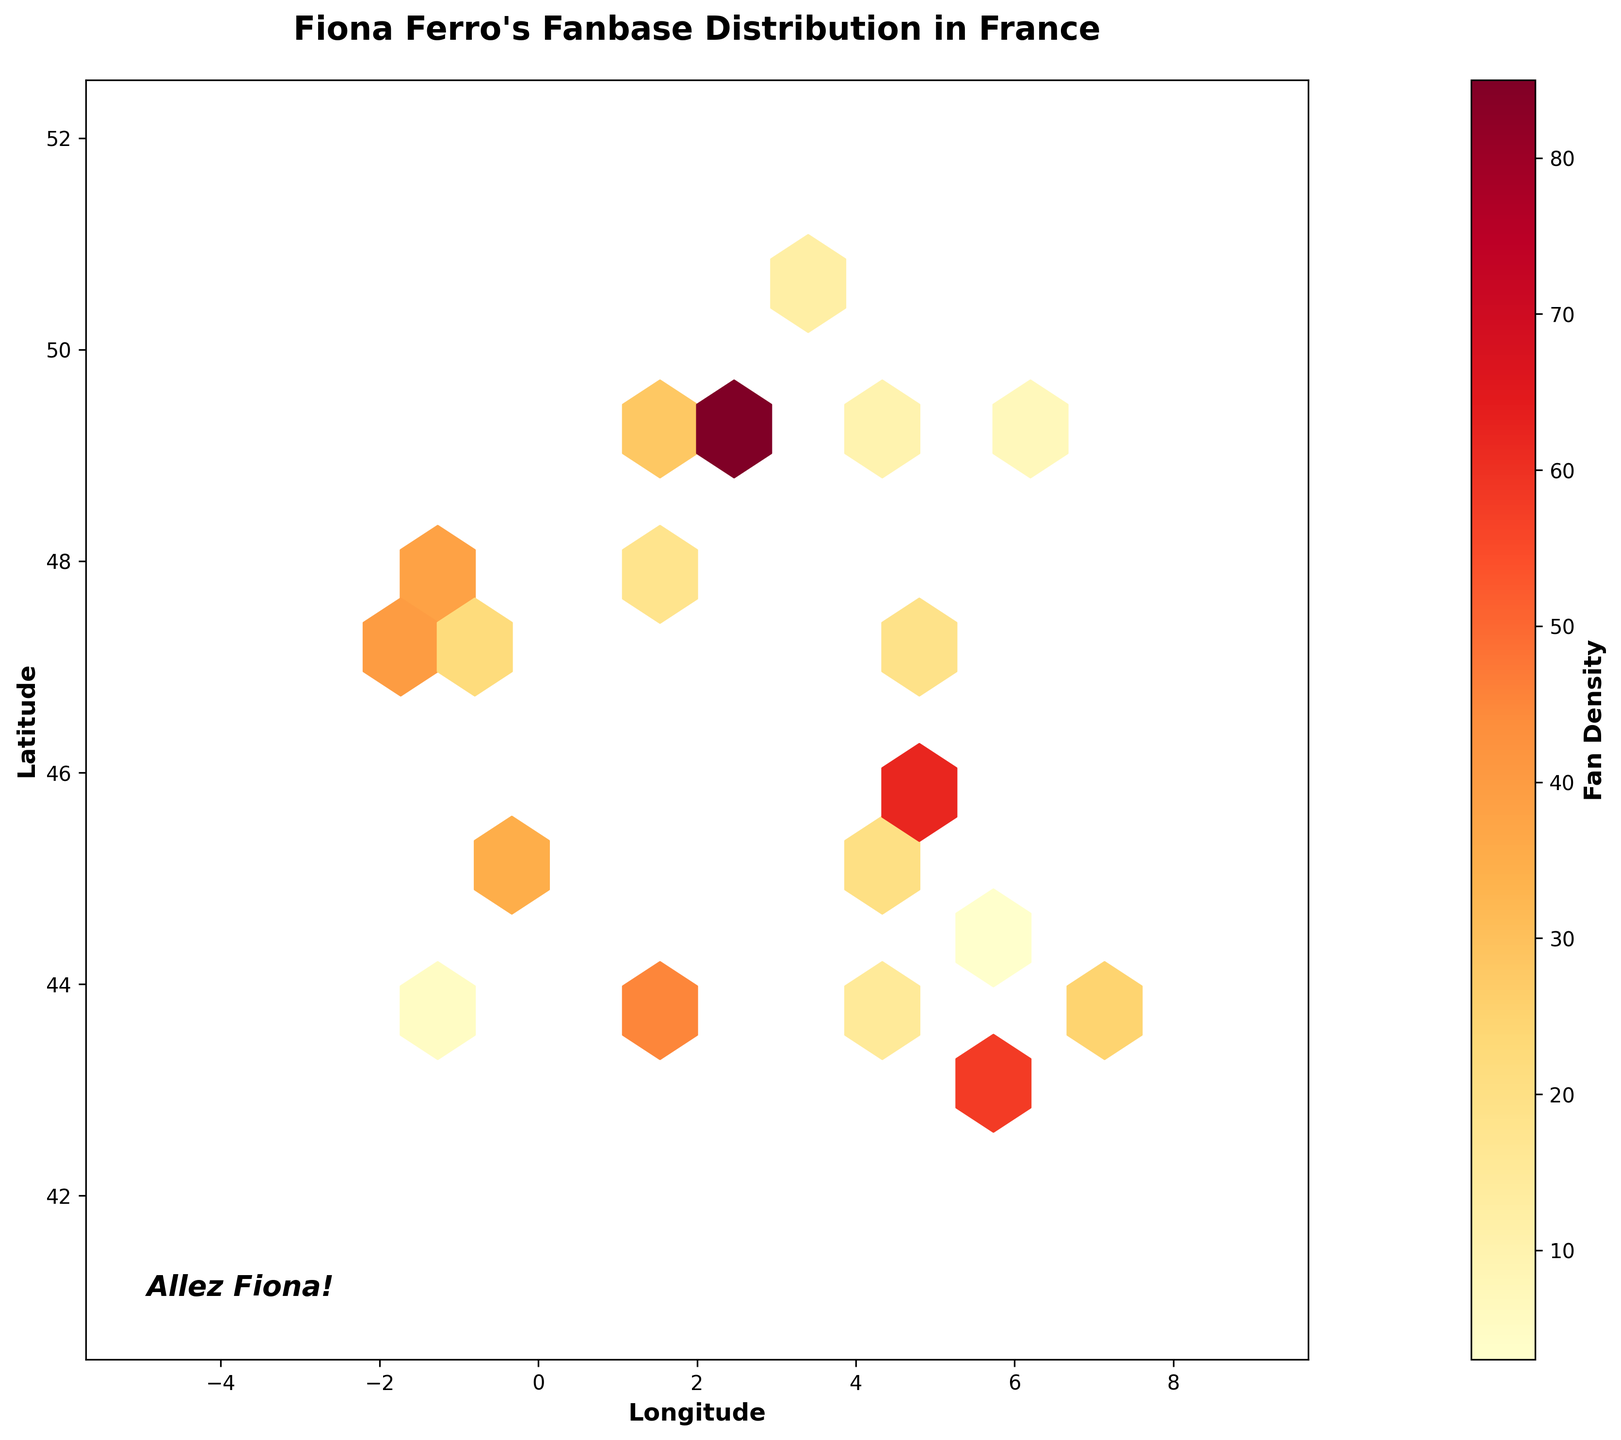What is the title of the hexbin plot? The title is located at the top of the plot. It provides context for the data shown in the figure. The title reads "Fiona Ferro's Fanbase Distribution in France."
Answer: Fiona Ferro's Fanbase Distribution in France What do the colors in the hexbin plot represent? The colors represent the density of Fiona Ferro's fanbase, with different shades indicating various fan densities. The color gradient runs from light yellow to red, marking increasing fan density.
Answer: Fan Density Which city has the highest fan density of Fiona Ferro? By observing the hexbin plot and looking at the color scale, it appears that the highest density, indicated by the darkest red color, is centered at the coordinates corresponding to Paris.
Answer: Paris What are the labels for the x and y axes? The labels for the axes are found adjacent to the axis lines. The x-axis is labeled 'Longitude' and the y-axis is labeled 'Latitude.'
Answer: Longitude, Latitude Compare the fan densities between Paris (48.8566, 2.3522) and Lyon (45.7640, 4.8357). Which city has a higher density? By checking the density values on the plot, Paris (85) has a higher fan density compared to Lyon (62). This is verified by the darker hexbin color around Paris.
Answer: Paris In which region of France do the highest concentrations of Fiona Ferro's fans appear? By examining the concentration of darker hexagons, the highest densities of fans appear to be in northern and central France. This includes Paris and its surrounding areas.
Answer: Northern and Central France What is the range of fan densities shown in the colorbar? The colorbar, situated to the right of the hexbin plot, ranges from a lighter color indicating lower densities to darker colors indicating higher densities. The numerical range is from 1 to 85.
Answer: 1 to 85 How does the fan density in Bordeaux (44.8378, -0.5792) compare to that in Nantes (47.2184, -1.5536)? By comparing the density values from the data, Bordeaux has a fan density of 35, while Nantes has a fan density of 40. Nantes has a higher density than Bordeaux.
Answer: Nantes If you had to add up the fan densities of the cities with the three highest densities, what would the total be? The three cities with the highest densities are Paris (85), Lyon (62), and Marseille (58). Adding these densities together gives 85 + 62 + 58 = 205.
Answer: 205 What is the approximate latitude and longitude range covered by the hexbin plot? The extent of the plot is indicated in the code and visually apparent. It ranges approximately from -5 to 9 in longitude and 41 to 52 in latitude.
Answer: Longitude: -5 to 9, Latitude: 41 to 52 